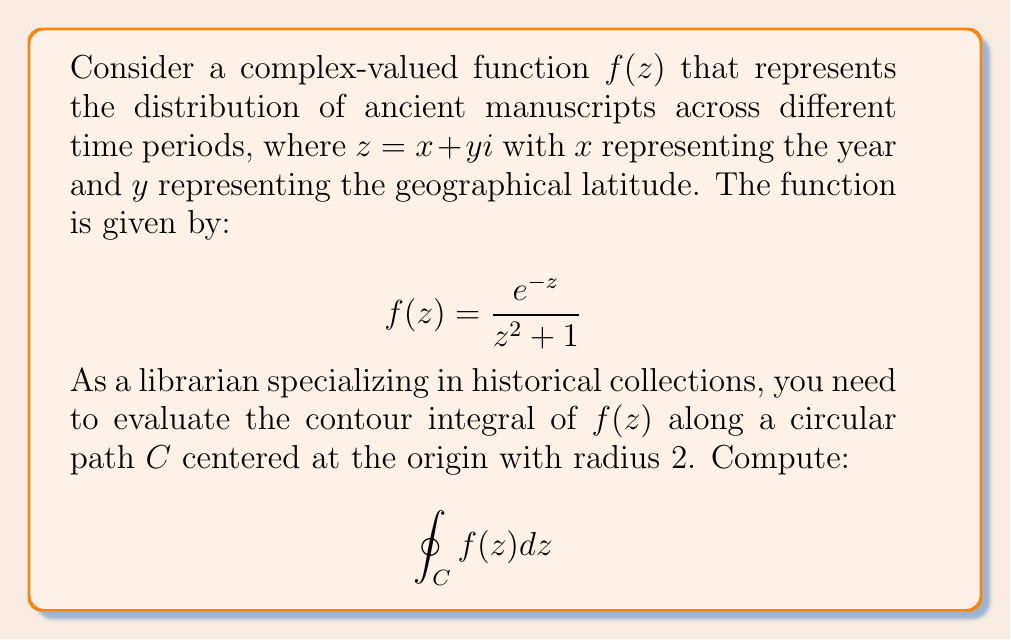Can you solve this math problem? To evaluate this contour integral, we'll use the Residue Theorem. Let's follow these steps:

1) First, we need to identify the singularities of $f(z)$ inside the contour $C$. The singularities are the points where the denominator is zero:

   $z^2 + 1 = 0$
   $z = \pm i$

   Only $z = i$ is inside our contour of radius 2.

2) Now, we need to calculate the residue at $z = i$. The residue is given by:

   $$\text{Res}(f, i) = \lim_{z \to i} (z-i)f(z) = \lim_{z \to i} \frac{(z-i)e^{-z}}{z^2 + 1}$$

3) Using L'Hôpital's rule:

   $$\text{Res}(f, i) = \lim_{z \to i} \frac{e^{-z} - (z-i)e^{-z}}{2z} = \frac{e^{-i}}{2i}$$

4) The Residue Theorem states that:

   $$\oint_C f(z) dz = 2\pi i \sum \text{Res}(f, a_k)$$

   where $a_k$ are the singularities inside $C$.

5) In our case, we have only one singularity, so:

   $$\oint_C f(z) dz = 2\pi i \cdot \frac{e^{-i}}{2i} = \pi e^{-i}$$

6) We can express this in terms of real and imaginary parts:

   $$\pi e^{-i} = \pi (\cos(-1) + i\sin(-1)) = \pi (\cos(1) - i\sin(1))$$
Answer: $$\pi (\cos(1) - i\sin(1))$$ 